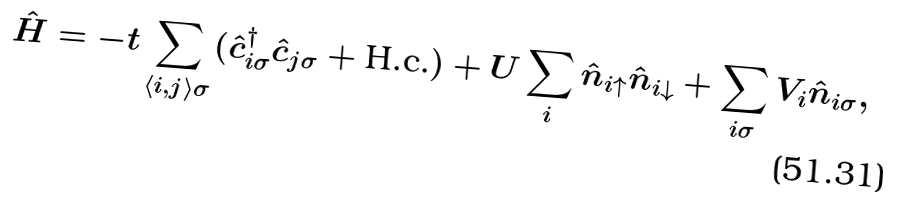<formula> <loc_0><loc_0><loc_500><loc_500>\hat { H } = - t \sum _ { \left < i , j \right > \sigma } ( \hat { c } ^ { \dagger } _ { i \sigma } \hat { c } _ { j \sigma } + \text {H.c.} ) + U \sum _ { i } \hat { n } _ { i \uparrow } \hat { n } _ { i \downarrow } + \sum _ { i \sigma } V _ { i } \hat { n } _ { i \sigma } ,</formula> 